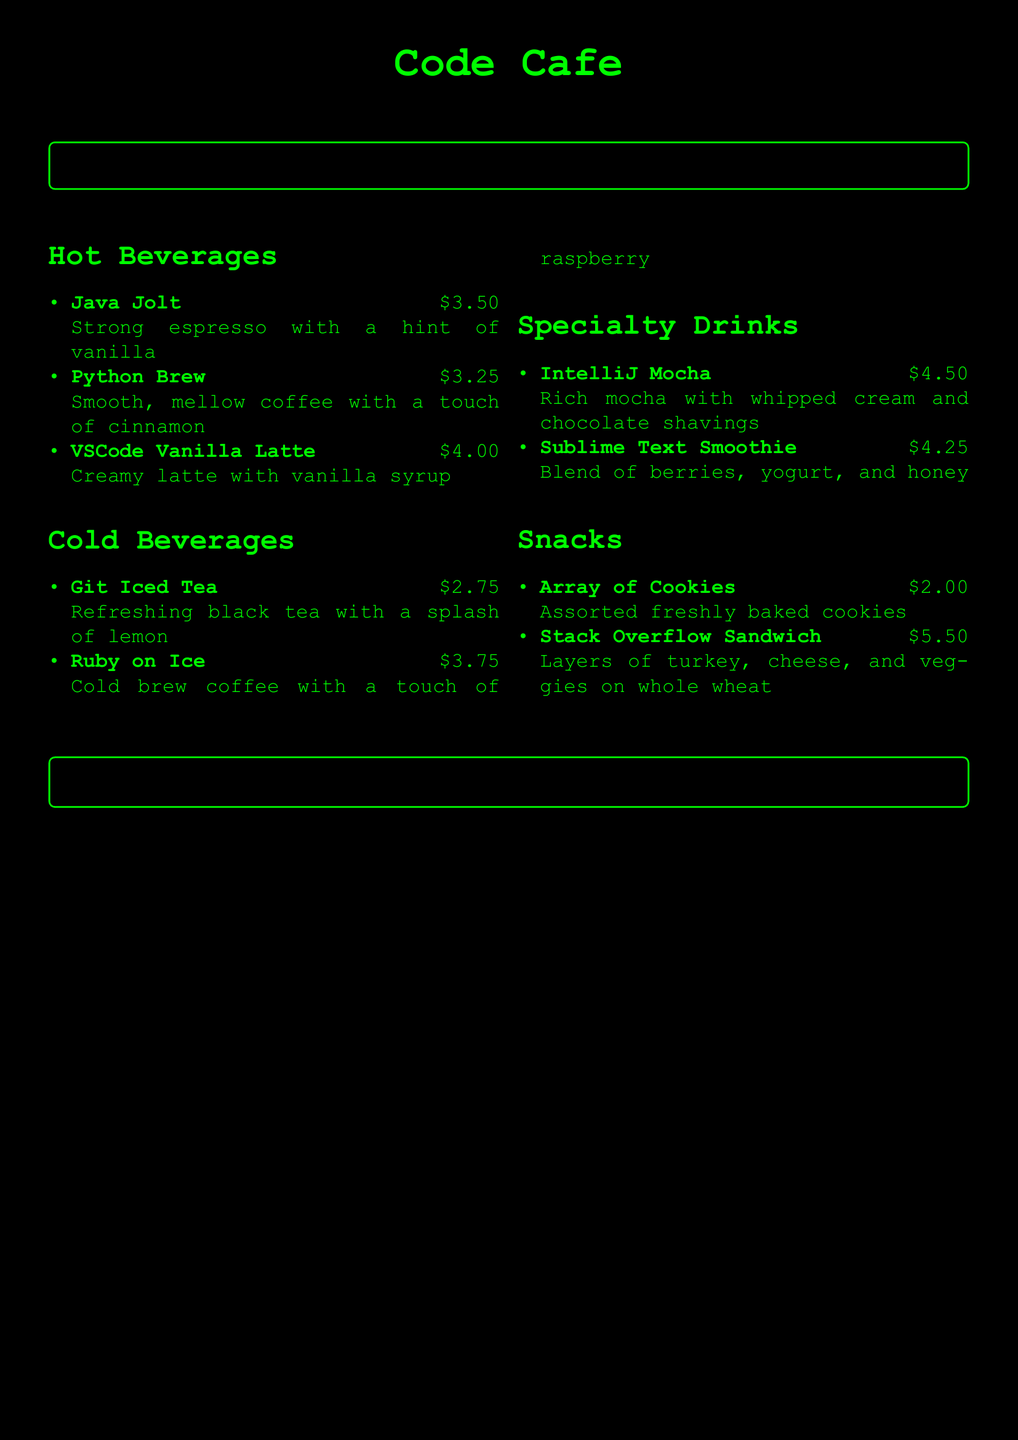What is the price of Java Jolt? The price of Java Jolt is listed in the menu under Hot Beverages.
Answer: $3.50 How much does a Ruby on Ice cost? The cost of Ruby on Ice is found in the Cold Beverages section.
Answer: $3.75 What type of drink is IntelliJ Mocha? IntelliJ Mocha is categorized under Specialty Drinks in the menu.
Answer: Mocha What is the main ingredient in Python Brew? The menu specifies that Python Brew has a touch of cinnamon.
Answer: Cinnamon Which drink is priced the highest? By comparing the prices listed in the menu, the drink with the highest price can be identified.
Answer: IntelliJ Mocha How many hot beverage options are on the menu? The menu lists three options under Hot Beverages, which can be counted.
Answer: 3 What type of item is Stack Overflow Sandwich? The menu describes Stack Overflow Sandwich which is categorized as a snack.
Answer: Sandwich What is included in the Array of Cookies? The Array of Cookies is described to offer assorted freshly baked cookies.
Answer: Assorted cookies 